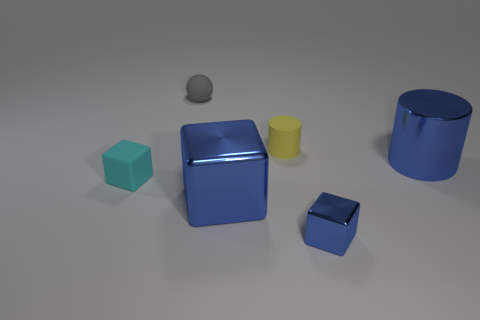What number of balls have the same size as the rubber cylinder?
Ensure brevity in your answer.  1. The small metal thing is what shape?
Give a very brief answer. Cube. What size is the thing that is both to the right of the yellow rubber cylinder and behind the big blue cube?
Your response must be concise. Large. There is a cylinder that is behind the big blue cylinder; what material is it?
Provide a succinct answer. Rubber. There is a metallic cylinder; is its color the same as the small block that is right of the small gray matte sphere?
Give a very brief answer. Yes. What number of objects are either cylinders that are in front of the yellow matte object or tiny things on the right side of the small rubber sphere?
Your response must be concise. 3. What is the color of the object that is both to the left of the small yellow thing and on the right side of the ball?
Your answer should be very brief. Blue. Are there more large cylinders than metal things?
Your answer should be compact. No. There is a tiny rubber thing that is in front of the big blue shiny cylinder; is its shape the same as the tiny blue thing?
Offer a terse response. Yes. How many metal objects are large blue cylinders or small yellow cylinders?
Offer a terse response. 1. 